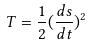Convert formula to latex. <formula><loc_0><loc_0><loc_500><loc_500>T = \frac { 1 } { 2 } ( \frac { d s } { d t } ) ^ { 2 }</formula> 